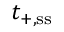Convert formula to latex. <formula><loc_0><loc_0><loc_500><loc_500>t _ { + , { s s } }</formula> 